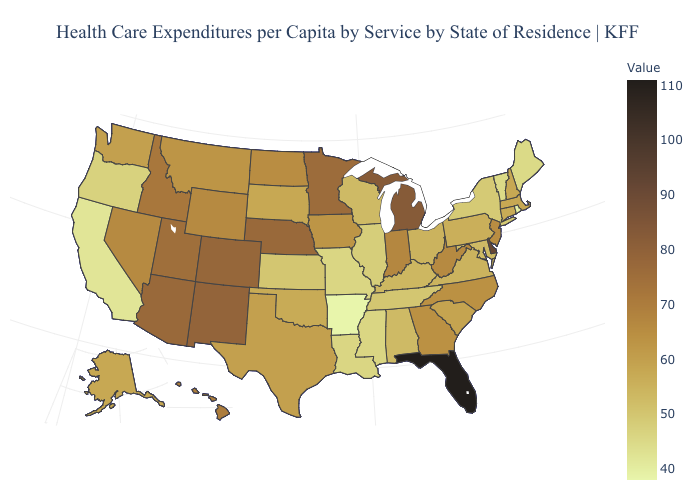Does Michigan have the highest value in the MidWest?
Write a very short answer. Yes. Among the states that border Louisiana , does Arkansas have the lowest value?
Concise answer only. Yes. Does Iowa have the highest value in the MidWest?
Be succinct. No. Does Missouri have the lowest value in the MidWest?
Concise answer only. Yes. Does South Dakota have the lowest value in the USA?
Short answer required. No. Does the map have missing data?
Give a very brief answer. No. Among the states that border New York , which have the lowest value?
Quick response, please. Vermont. Which states have the lowest value in the MidWest?
Keep it brief. Missouri. Among the states that border Missouri , which have the lowest value?
Answer briefly. Arkansas. Among the states that border Colorado , which have the highest value?
Concise answer only. New Mexico. Which states hav the highest value in the MidWest?
Quick response, please. Michigan. 